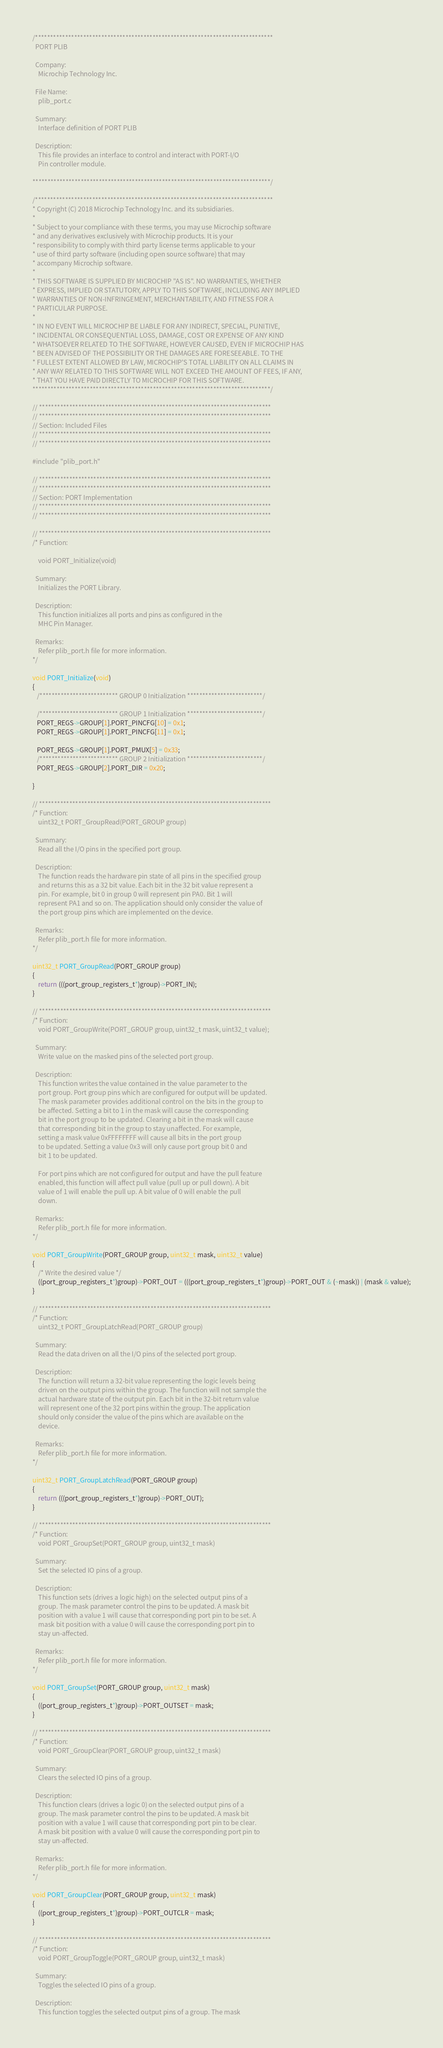Convert code to text. <code><loc_0><loc_0><loc_500><loc_500><_C_>/*******************************************************************************
  PORT PLIB

  Company:
    Microchip Technology Inc.

  File Name:
    plib_port.c

  Summary:
    Interface definition of PORT PLIB

  Description:
    This file provides an interface to control and interact with PORT-I/O
    Pin controller module.

*******************************************************************************/

/*******************************************************************************
* Copyright (C) 2018 Microchip Technology Inc. and its subsidiaries.
*
* Subject to your compliance with these terms, you may use Microchip software
* and any derivatives exclusively with Microchip products. It is your
* responsibility to comply with third party license terms applicable to your
* use of third party software (including open source software) that may
* accompany Microchip software.
*
* THIS SOFTWARE IS SUPPLIED BY MICROCHIP "AS IS". NO WARRANTIES, WHETHER
* EXPRESS, IMPLIED OR STATUTORY, APPLY TO THIS SOFTWARE, INCLUDING ANY IMPLIED
* WARRANTIES OF NON-INFRINGEMENT, MERCHANTABILITY, AND FITNESS FOR A
* PARTICULAR PURPOSE.
*
* IN NO EVENT WILL MICROCHIP BE LIABLE FOR ANY INDIRECT, SPECIAL, PUNITIVE,
* INCIDENTAL OR CONSEQUENTIAL LOSS, DAMAGE, COST OR EXPENSE OF ANY KIND
* WHATSOEVER RELATED TO THE SOFTWARE, HOWEVER CAUSED, EVEN IF MICROCHIP HAS
* BEEN ADVISED OF THE POSSIBILITY OR THE DAMAGES ARE FORESEEABLE. TO THE
* FULLEST EXTENT ALLOWED BY LAW, MICROCHIP'S TOTAL LIABILITY ON ALL CLAIMS IN
* ANY WAY RELATED TO THIS SOFTWARE WILL NOT EXCEED THE AMOUNT OF FEES, IF ANY,
* THAT YOU HAVE PAID DIRECTLY TO MICROCHIP FOR THIS SOFTWARE.
*******************************************************************************/

// *****************************************************************************
// *****************************************************************************
// Section: Included Files
// *****************************************************************************
// *****************************************************************************

#include "plib_port.h"

// *****************************************************************************
// *****************************************************************************
// Section: PORT Implementation
// *****************************************************************************
// *****************************************************************************

// *****************************************************************************
/* Function:

    void PORT_Initialize(void)

  Summary:
    Initializes the PORT Library.

  Description:
    This function initializes all ports and pins as configured in the
    MHC Pin Manager.

  Remarks:
    Refer plib_port.h file for more information.
*/

void PORT_Initialize(void)
{
   /************************** GROUP 0 Initialization *************************/

   /************************** GROUP 1 Initialization *************************/
   PORT_REGS->GROUP[1].PORT_PINCFG[10] = 0x1;
   PORT_REGS->GROUP[1].PORT_PINCFG[11] = 0x1;

   PORT_REGS->GROUP[1].PORT_PMUX[5] = 0x33;
   /************************** GROUP 2 Initialization *************************/
   PORT_REGS->GROUP[2].PORT_DIR = 0x20;

}

// *****************************************************************************
/* Function:
    uint32_t PORT_GroupRead(PORT_GROUP group)

  Summary:
    Read all the I/O pins in the specified port group.

  Description:
    The function reads the hardware pin state of all pins in the specified group
    and returns this as a 32 bit value. Each bit in the 32 bit value represent a
    pin. For example, bit 0 in group 0 will represent pin PA0. Bit 1 will
    represent PA1 and so on. The application should only consider the value of
    the port group pins which are implemented on the device.

  Remarks:
    Refer plib_port.h file for more information.
*/

uint32_t PORT_GroupRead(PORT_GROUP group)
{
    return (((port_group_registers_t*)group)->PORT_IN);
}

// *****************************************************************************
/* Function:
    void PORT_GroupWrite(PORT_GROUP group, uint32_t mask, uint32_t value);

  Summary:
    Write value on the masked pins of the selected port group.

  Description:
    This function writes the value contained in the value parameter to the
    port group. Port group pins which are configured for output will be updated.
    The mask parameter provides additional control on the bits in the group to
    be affected. Setting a bit to 1 in the mask will cause the corresponding
    bit in the port group to be updated. Clearing a bit in the mask will cause
    that corresponding bit in the group to stay unaffected. For example,
    setting a mask value 0xFFFFFFFF will cause all bits in the port group
    to be updated. Setting a value 0x3 will only cause port group bit 0 and
    bit 1 to be updated.

    For port pins which are not configured for output and have the pull feature
    enabled, this function will affect pull value (pull up or pull down). A bit
    value of 1 will enable the pull up. A bit value of 0 will enable the pull
    down.

  Remarks:
    Refer plib_port.h file for more information.
*/

void PORT_GroupWrite(PORT_GROUP group, uint32_t mask, uint32_t value)
{
    /* Write the desired value */
    ((port_group_registers_t*)group)->PORT_OUT = (((port_group_registers_t*)group)->PORT_OUT & (~mask)) | (mask & value);
}

// *****************************************************************************
/* Function:
    uint32_t PORT_GroupLatchRead(PORT_GROUP group)

  Summary:
    Read the data driven on all the I/O pins of the selected port group.

  Description:
    The function will return a 32-bit value representing the logic levels being
    driven on the output pins within the group. The function will not sample the
    actual hardware state of the output pin. Each bit in the 32-bit return value
    will represent one of the 32 port pins within the group. The application
    should only consider the value of the pins which are available on the
    device.

  Remarks:
    Refer plib_port.h file for more information.
*/

uint32_t PORT_GroupLatchRead(PORT_GROUP group)
{
    return (((port_group_registers_t*)group)->PORT_OUT);
}

// *****************************************************************************
/* Function:
    void PORT_GroupSet(PORT_GROUP group, uint32_t mask)

  Summary:
    Set the selected IO pins of a group.

  Description:
    This function sets (drives a logic high) on the selected output pins of a
    group. The mask parameter control the pins to be updated. A mask bit
    position with a value 1 will cause that corresponding port pin to be set. A
    mask bit position with a value 0 will cause the corresponding port pin to
    stay un-affected.

  Remarks:
    Refer plib_port.h file for more information.
*/

void PORT_GroupSet(PORT_GROUP group, uint32_t mask)
{
    ((port_group_registers_t*)group)->PORT_OUTSET = mask;
}

// *****************************************************************************
/* Function:
    void PORT_GroupClear(PORT_GROUP group, uint32_t mask)

  Summary:
    Clears the selected IO pins of a group.

  Description:
    This function clears (drives a logic 0) on the selected output pins of a
    group. The mask parameter control the pins to be updated. A mask bit
    position with a value 1 will cause that corresponding port pin to be clear.
    A mask bit position with a value 0 will cause the corresponding port pin to
    stay un-affected.

  Remarks:
    Refer plib_port.h file for more information.
*/

void PORT_GroupClear(PORT_GROUP group, uint32_t mask)
{
    ((port_group_registers_t*)group)->PORT_OUTCLR = mask;
}

// *****************************************************************************
/* Function:
    void PORT_GroupToggle(PORT_GROUP group, uint32_t mask)

  Summary:
    Toggles the selected IO pins of a group.

  Description:
    This function toggles the selected output pins of a group. The mask</code> 